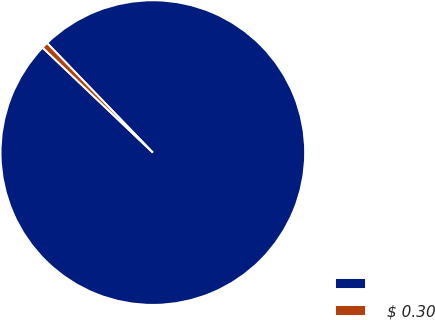<chart> <loc_0><loc_0><loc_500><loc_500><pie_chart><ecel><fcel>$ 0.30<nl><fcel>99.33%<fcel>0.67%<nl></chart> 